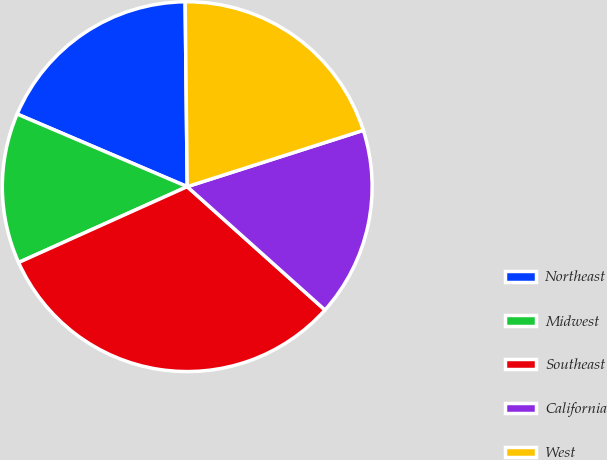Convert chart. <chart><loc_0><loc_0><loc_500><loc_500><pie_chart><fcel>Northeast<fcel>Midwest<fcel>Southeast<fcel>California<fcel>West<nl><fcel>18.4%<fcel>13.15%<fcel>31.65%<fcel>16.55%<fcel>20.25%<nl></chart> 